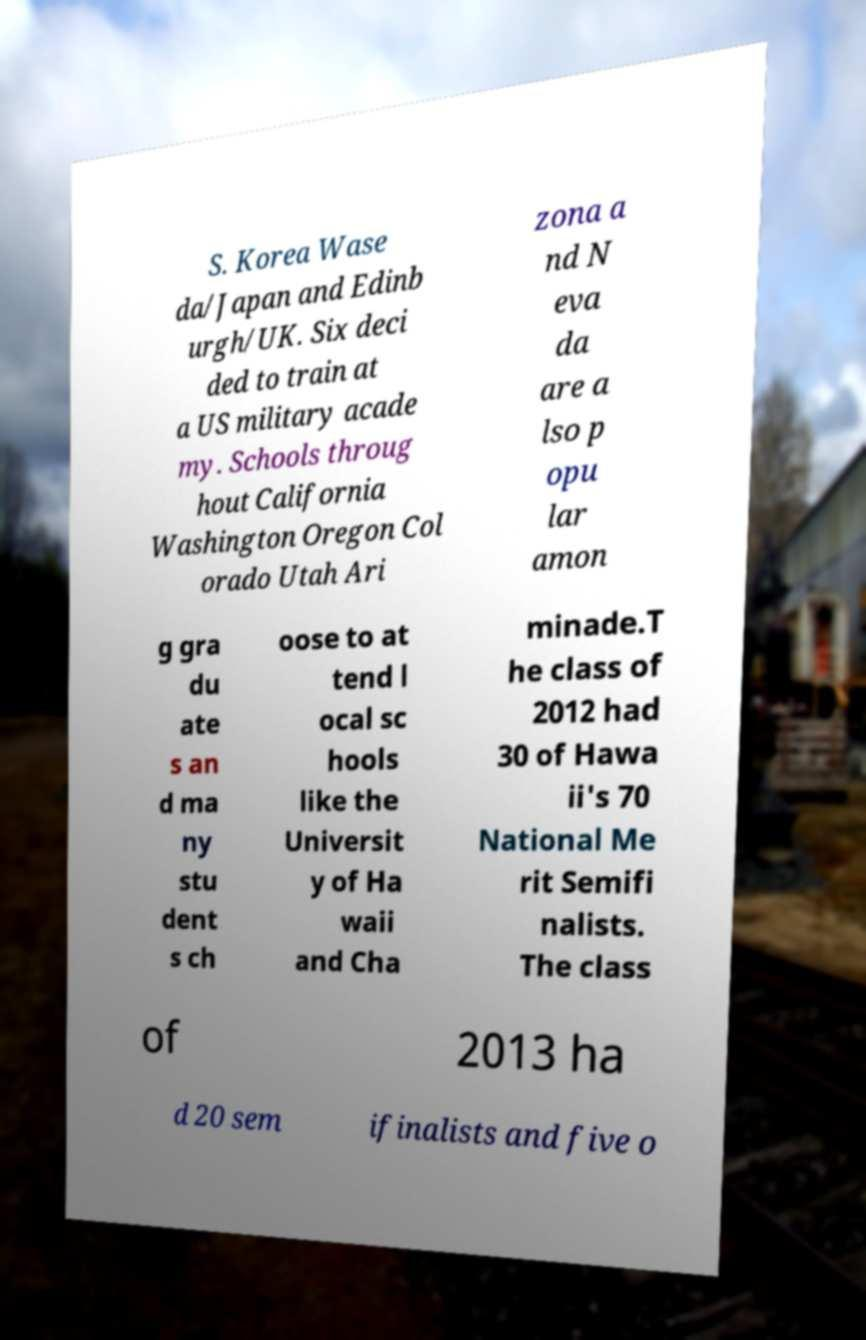Could you extract and type out the text from this image? S. Korea Wase da/Japan and Edinb urgh/UK. Six deci ded to train at a US military acade my. Schools throug hout California Washington Oregon Col orado Utah Ari zona a nd N eva da are a lso p opu lar amon g gra du ate s an d ma ny stu dent s ch oose to at tend l ocal sc hools like the Universit y of Ha waii and Cha minade.T he class of 2012 had 30 of Hawa ii's 70 National Me rit Semifi nalists. The class of 2013 ha d 20 sem ifinalists and five o 